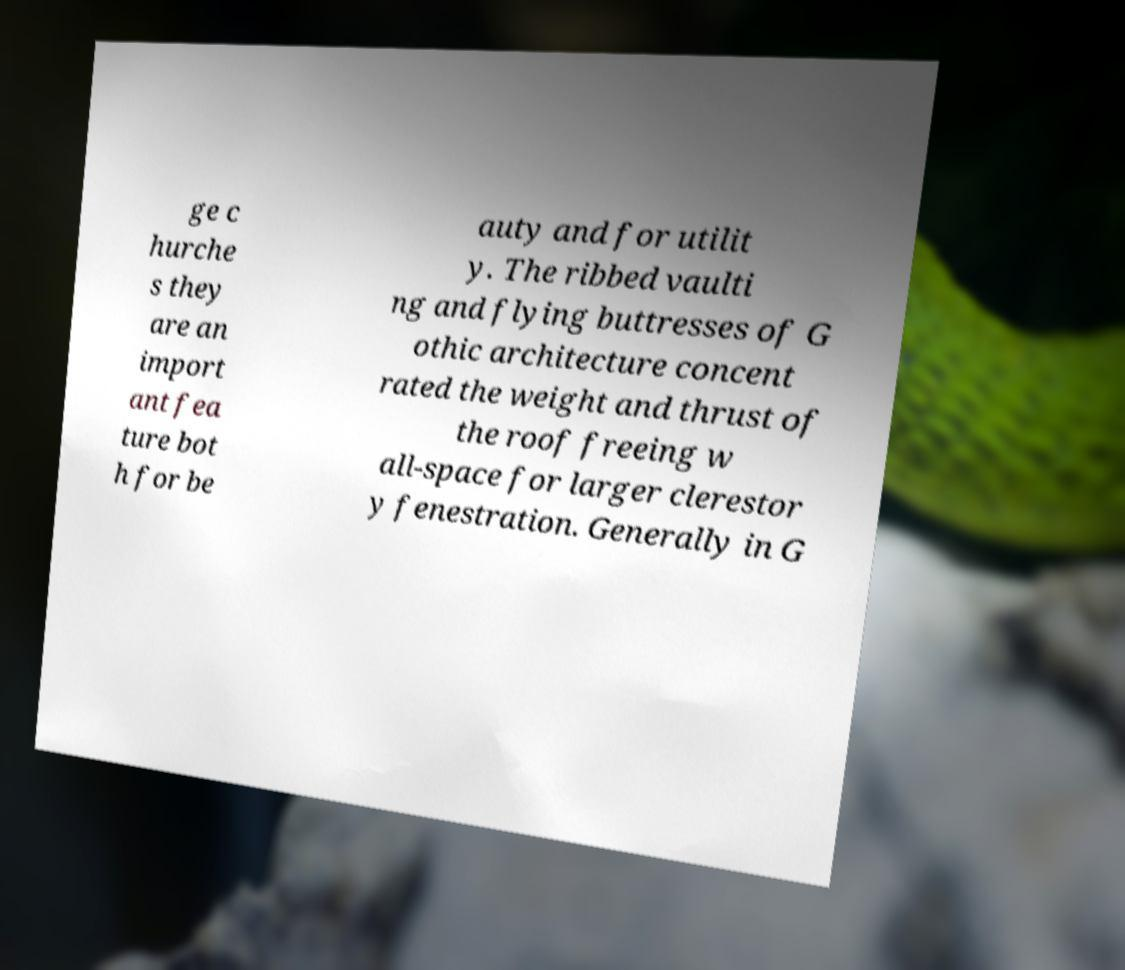There's text embedded in this image that I need extracted. Can you transcribe it verbatim? ge c hurche s they are an import ant fea ture bot h for be auty and for utilit y. The ribbed vaulti ng and flying buttresses of G othic architecture concent rated the weight and thrust of the roof freeing w all-space for larger clerestor y fenestration. Generally in G 